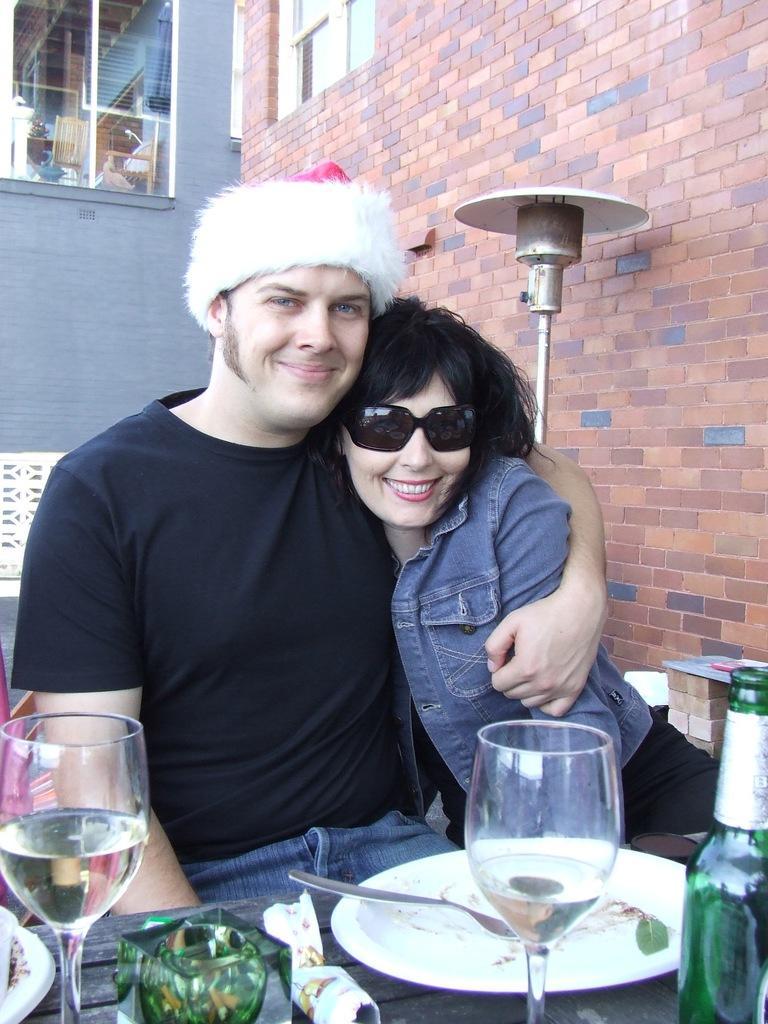How would you summarize this image in a sentence or two? In this image, there are two persons beside the wall sitting in front of the table. This table contains glasses, plate and bottle. There is a window at the top of the image. 